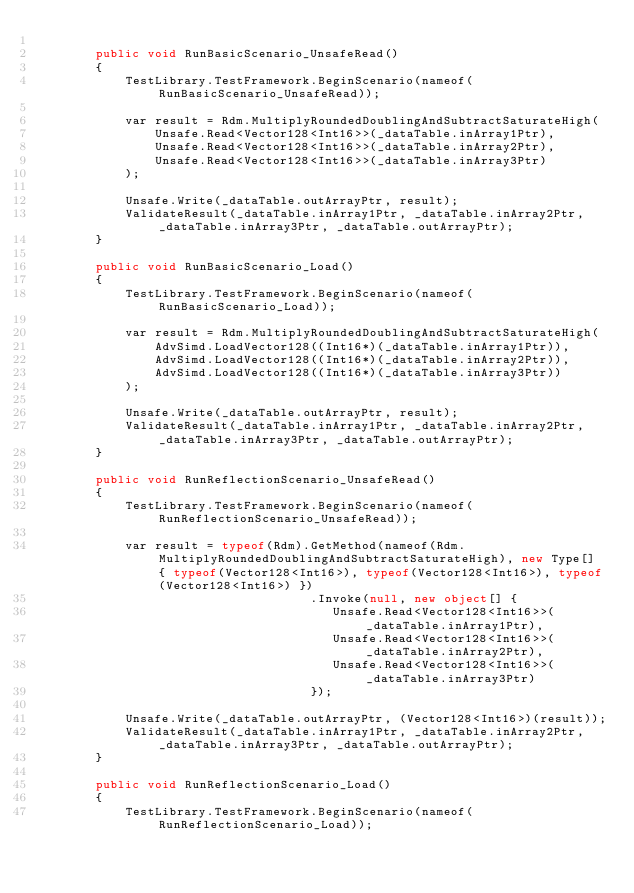<code> <loc_0><loc_0><loc_500><loc_500><_C#_>
        public void RunBasicScenario_UnsafeRead()
        {
            TestLibrary.TestFramework.BeginScenario(nameof(RunBasicScenario_UnsafeRead));

            var result = Rdm.MultiplyRoundedDoublingAndSubtractSaturateHigh(
                Unsafe.Read<Vector128<Int16>>(_dataTable.inArray1Ptr),
                Unsafe.Read<Vector128<Int16>>(_dataTable.inArray2Ptr),
                Unsafe.Read<Vector128<Int16>>(_dataTable.inArray3Ptr)
            );

            Unsafe.Write(_dataTable.outArrayPtr, result);
            ValidateResult(_dataTable.inArray1Ptr, _dataTable.inArray2Ptr, _dataTable.inArray3Ptr, _dataTable.outArrayPtr);
        }

        public void RunBasicScenario_Load()
        {
            TestLibrary.TestFramework.BeginScenario(nameof(RunBasicScenario_Load));

            var result = Rdm.MultiplyRoundedDoublingAndSubtractSaturateHigh(
                AdvSimd.LoadVector128((Int16*)(_dataTable.inArray1Ptr)),
                AdvSimd.LoadVector128((Int16*)(_dataTable.inArray2Ptr)),
                AdvSimd.LoadVector128((Int16*)(_dataTable.inArray3Ptr))
            );

            Unsafe.Write(_dataTable.outArrayPtr, result);
            ValidateResult(_dataTable.inArray1Ptr, _dataTable.inArray2Ptr, _dataTable.inArray3Ptr, _dataTable.outArrayPtr);
        }

        public void RunReflectionScenario_UnsafeRead()
        {
            TestLibrary.TestFramework.BeginScenario(nameof(RunReflectionScenario_UnsafeRead));

            var result = typeof(Rdm).GetMethod(nameof(Rdm.MultiplyRoundedDoublingAndSubtractSaturateHigh), new Type[] { typeof(Vector128<Int16>), typeof(Vector128<Int16>), typeof(Vector128<Int16>) })
                                     .Invoke(null, new object[] {
                                        Unsafe.Read<Vector128<Int16>>(_dataTable.inArray1Ptr),
                                        Unsafe.Read<Vector128<Int16>>(_dataTable.inArray2Ptr),
                                        Unsafe.Read<Vector128<Int16>>(_dataTable.inArray3Ptr)
                                     });

            Unsafe.Write(_dataTable.outArrayPtr, (Vector128<Int16>)(result));
            ValidateResult(_dataTable.inArray1Ptr, _dataTable.inArray2Ptr, _dataTable.inArray3Ptr, _dataTable.outArrayPtr);
        }

        public void RunReflectionScenario_Load()
        {
            TestLibrary.TestFramework.BeginScenario(nameof(RunReflectionScenario_Load));
</code> 